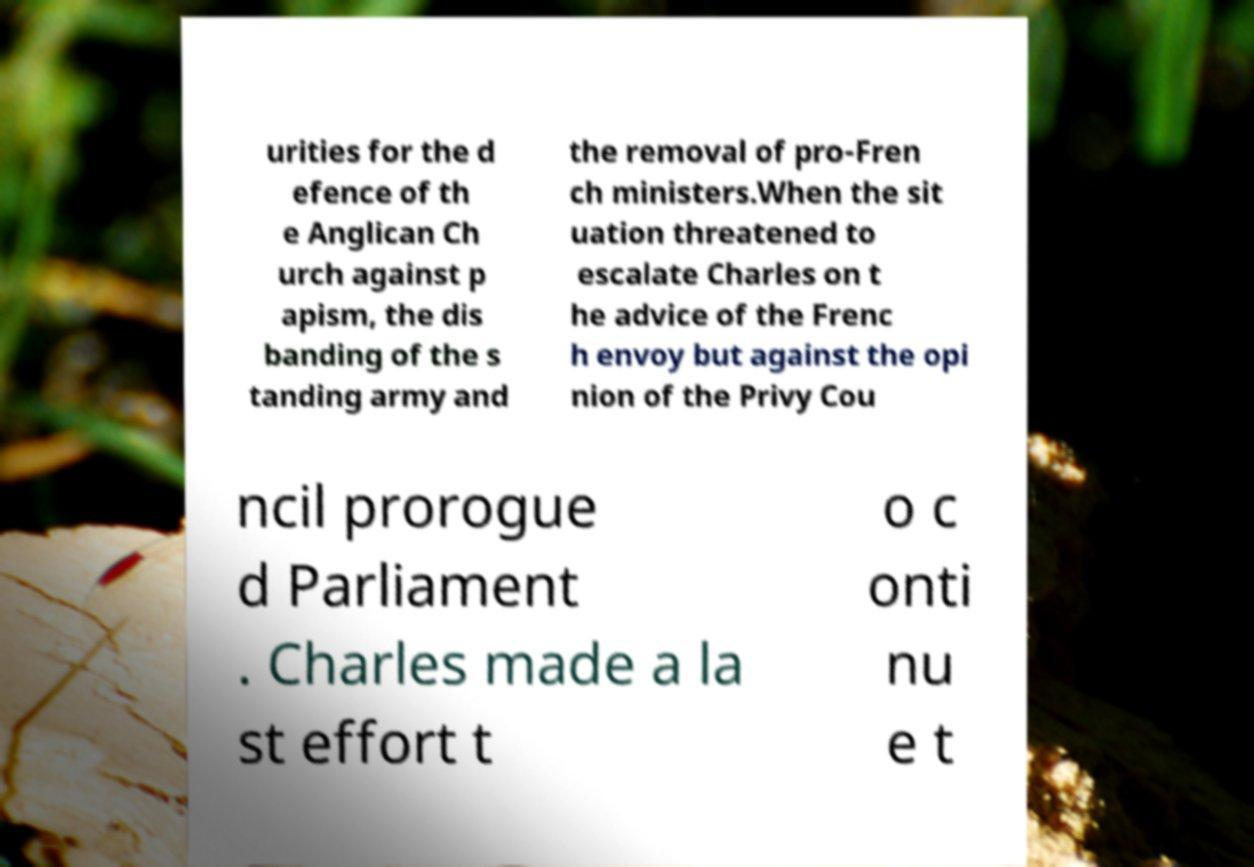I need the written content from this picture converted into text. Can you do that? urities for the d efence of th e Anglican Ch urch against p apism, the dis banding of the s tanding army and the removal of pro-Fren ch ministers.When the sit uation threatened to escalate Charles on t he advice of the Frenc h envoy but against the opi nion of the Privy Cou ncil prorogue d Parliament . Charles made a la st effort t o c onti nu e t 